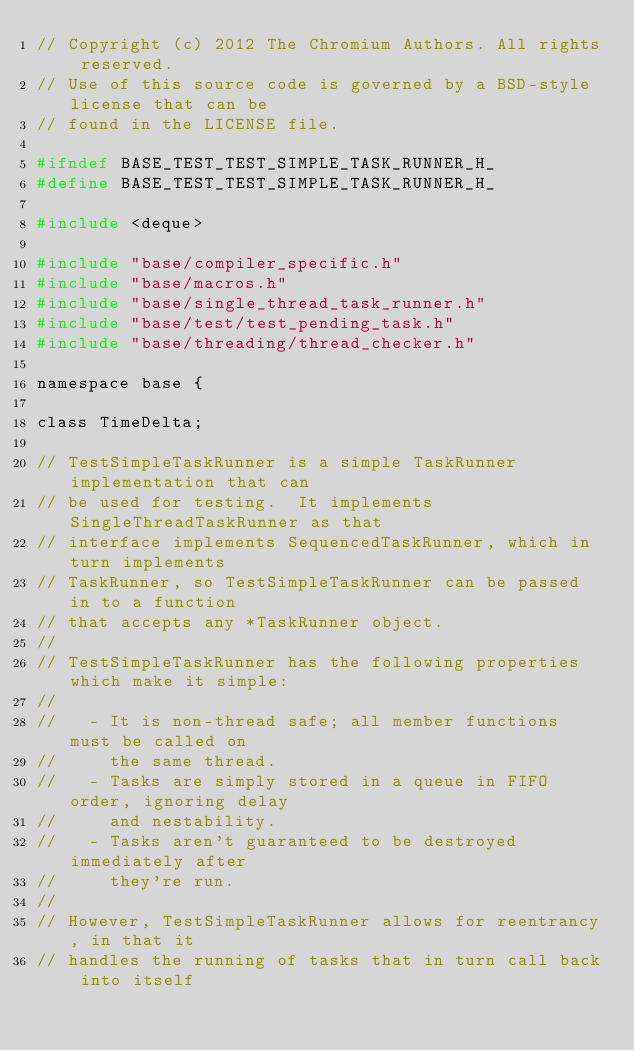Convert code to text. <code><loc_0><loc_0><loc_500><loc_500><_C_>// Copyright (c) 2012 The Chromium Authors. All rights reserved.
// Use of this source code is governed by a BSD-style license that can be
// found in the LICENSE file.

#ifndef BASE_TEST_TEST_SIMPLE_TASK_RUNNER_H_
#define BASE_TEST_TEST_SIMPLE_TASK_RUNNER_H_

#include <deque>

#include "base/compiler_specific.h"
#include "base/macros.h"
#include "base/single_thread_task_runner.h"
#include "base/test/test_pending_task.h"
#include "base/threading/thread_checker.h"

namespace base {

class TimeDelta;

// TestSimpleTaskRunner is a simple TaskRunner implementation that can
// be used for testing.  It implements SingleThreadTaskRunner as that
// interface implements SequencedTaskRunner, which in turn implements
// TaskRunner, so TestSimpleTaskRunner can be passed in to a function
// that accepts any *TaskRunner object.
//
// TestSimpleTaskRunner has the following properties which make it simple:
//
//   - It is non-thread safe; all member functions must be called on
//     the same thread.
//   - Tasks are simply stored in a queue in FIFO order, ignoring delay
//     and nestability.
//   - Tasks aren't guaranteed to be destroyed immediately after
//     they're run.
//
// However, TestSimpleTaskRunner allows for reentrancy, in that it
// handles the running of tasks that in turn call back into itself</code> 